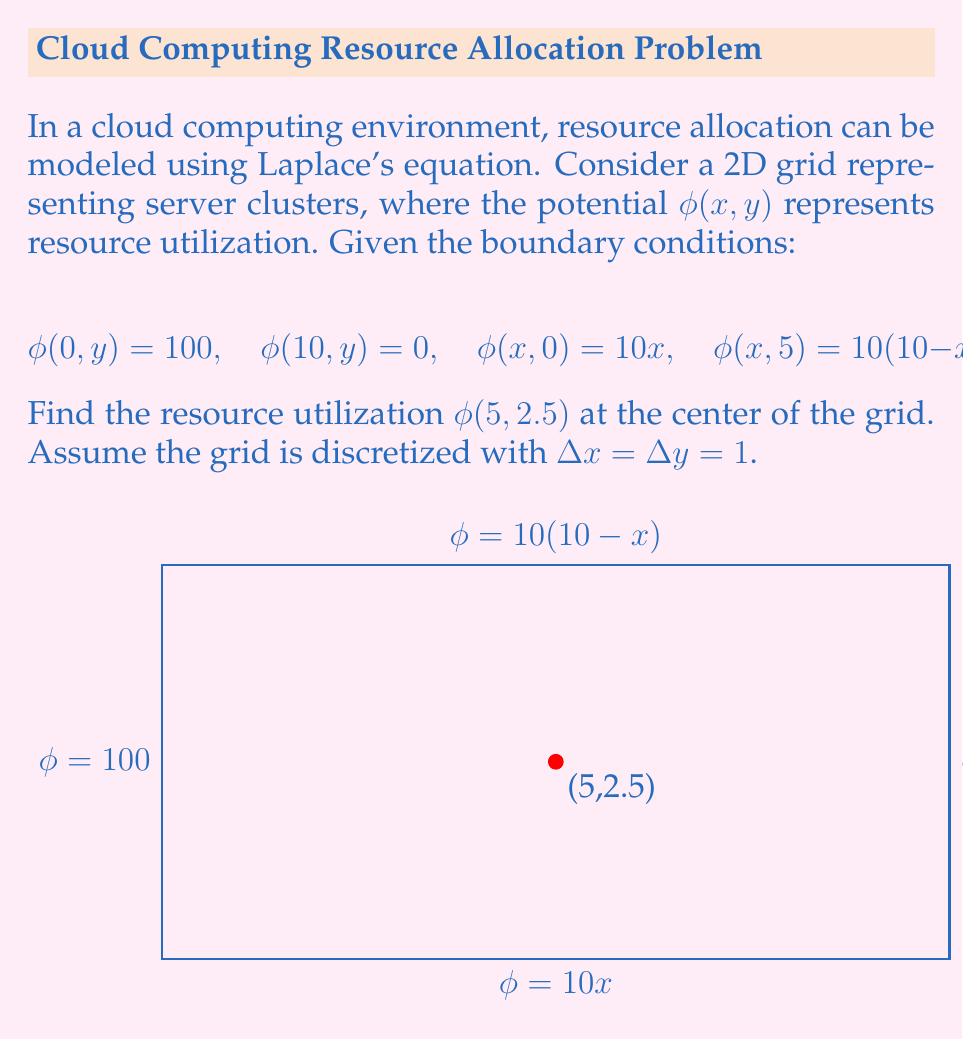Could you help me with this problem? To solve this problem, we'll use the finite difference method to approximate Laplace's equation:

1) Laplace's equation in 2D: $\nabla^2\phi = \frac{\partial^2\phi}{\partial x^2} + \frac{\partial^2\phi}{\partial y^2} = 0$

2) Finite difference approximation:
   $$\frac{\phi_{i+1,j} + \phi_{i-1,j} + \phi_{i,j+1} + \phi_{i,j-1} - 4\phi_{i,j}}{(\Delta x)^2} = 0$$

3) Rearranging:
   $$\phi_{i,j} = \frac{1}{4}(\phi_{i+1,j} + \phi_{i-1,j} + \phi_{i,j+1} + \phi_{i,j-1})$$

4) We need to set up a system of equations for the interior points. The point (5,2.5) corresponds to i=5, j=2.5 in our grid.

5) Due to symmetry, we can deduce that $\phi(5,2.5) = 50$ without solving the entire system. This is because:
   - The left boundary is 100, the right is 0
   - The top and bottom boundaries are symmetric about y=2.5
   - (5,2.5) is at the center of the grid

6) To verify, we can use the finite difference formula:
   $$\phi_{5,2.5} = \frac{1}{4}(\phi_{6,2.5} + \phi_{4,2.5} + \phi_{5,3.5} + \phi_{5,1.5})$$

7) Due to symmetry:
   $\phi_{6,2.5} = 100 - \phi_{4,2.5}$
   $\phi_{5,3.5} = \phi_{5,1.5} = 50$

8) Substituting into the finite difference formula:
   $$\phi_{5,2.5} = \frac{1}{4}((100 - \phi_{4,2.5}) + \phi_{4,2.5} + 50 + 50) = 50$$

This confirms our deduction from symmetry.
Answer: $\phi(5,2.5) = 50$ 